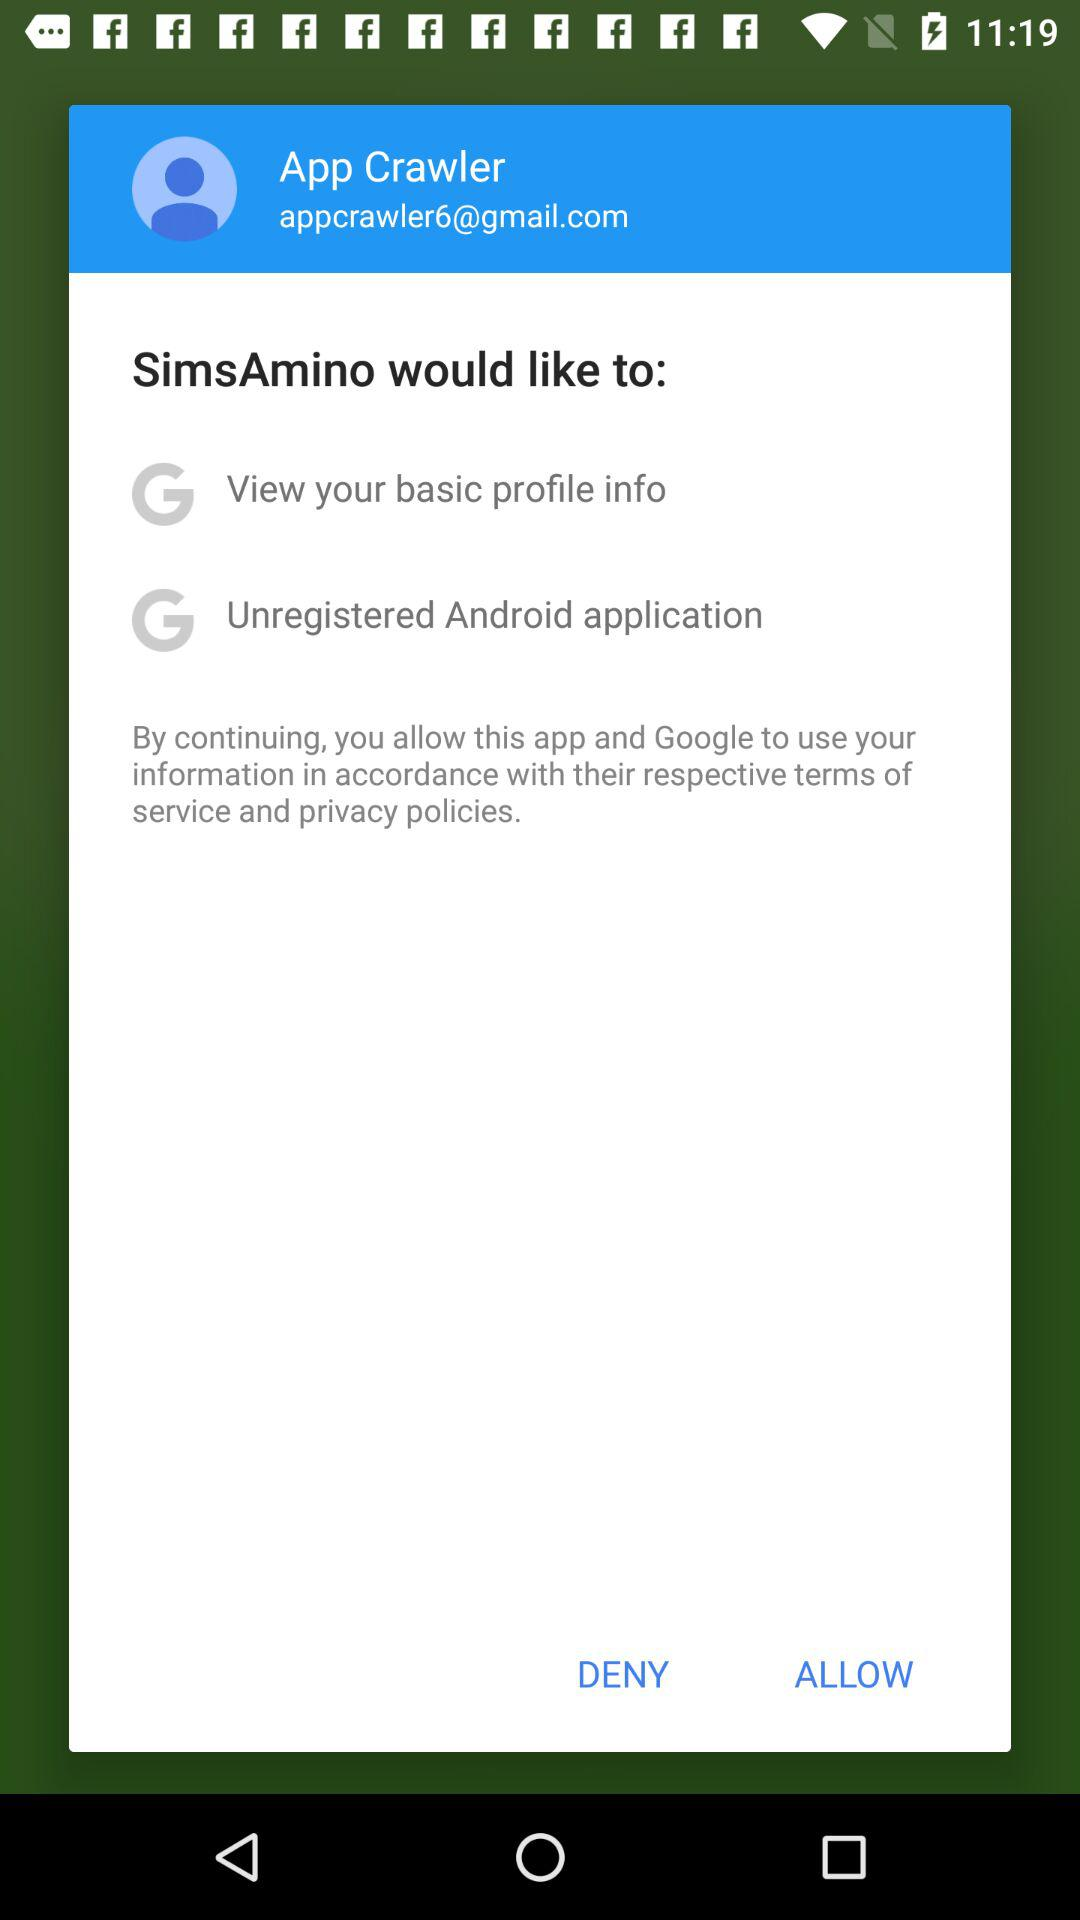What is the email address? The email address is appcrawler6@gmail.com. 